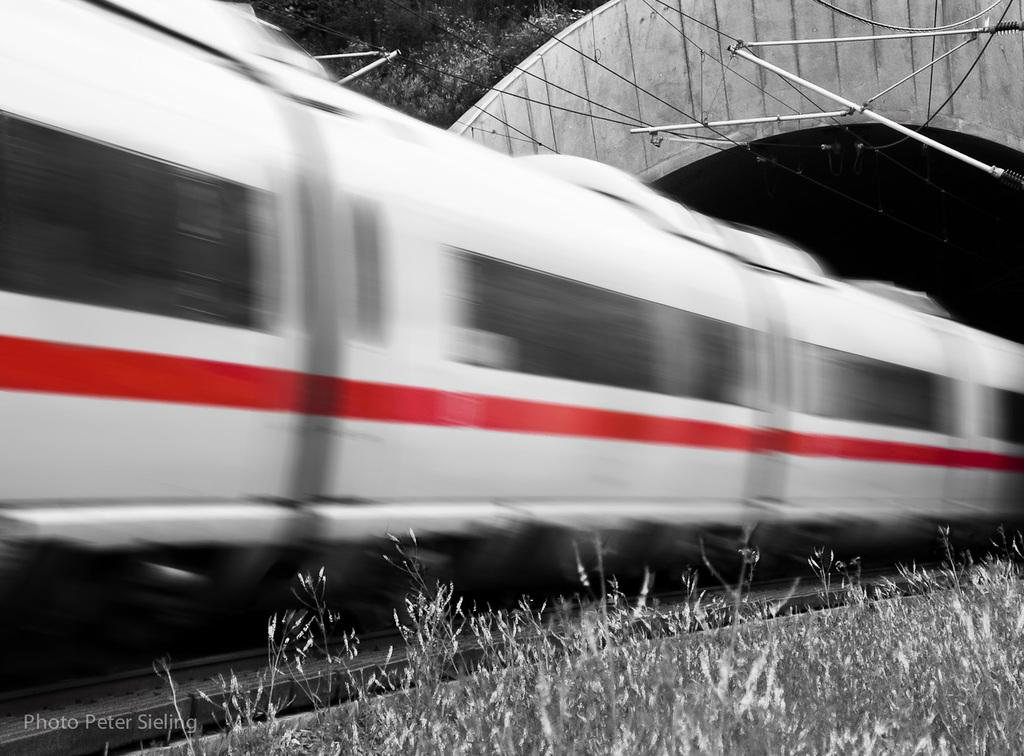What is the main subject of the image? There is a train in the image. Where is the train located? The train is on a train track. What is visible above the train in the image? There is a roof visible in the image. What else can be seen in the image besides the train and roof? Wires and plants are present in the image. What type of scent can be detected coming from the train in the image? There is no indication of a scent in the image, as it only shows a train on a train track, a roof, wires, and plants. 